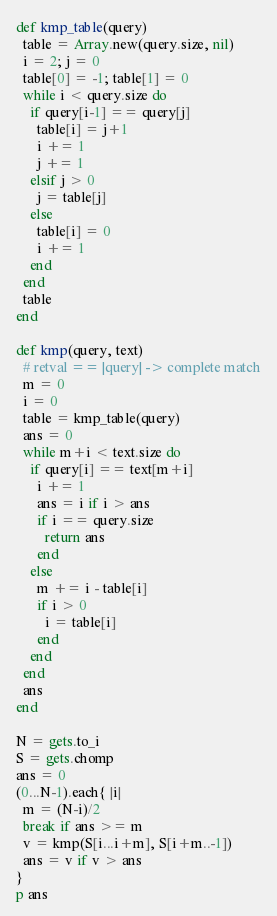Convert code to text. <code><loc_0><loc_0><loc_500><loc_500><_Ruby_>def kmp_table(query)
  table = Array.new(query.size, nil)
  i = 2; j = 0
  table[0] = -1; table[1] = 0
  while i < query.size do
    if query[i-1] == query[j]
      table[i] = j+1
      i += 1
      j += 1
    elsif j > 0
      j = table[j]
    else
      table[i] = 0
      i += 1
    end
  end 
  table
end

def kmp(query, text)
  # retval == |query| -> complete match
  m = 0
  i = 0
  table = kmp_table(query)
  ans = 0
  while m+i < text.size do
    if query[i] == text[m+i]
      i += 1
      ans = i if i > ans
      if i == query.size
        return ans
      end
    else
      m += i - table[i]
      if i > 0
        i = table[i]
      end
    end
  end
  ans
end

N = gets.to_i
S = gets.chomp
ans = 0
(0...N-1).each{ |i|
  m = (N-i)/2
  break if ans >= m
  v = kmp(S[i...i+m], S[i+m..-1])
  ans = v if v > ans
}
p ans
</code> 